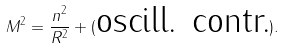Convert formula to latex. <formula><loc_0><loc_0><loc_500><loc_500>M ^ { 2 } = \frac { n ^ { 2 } } { R ^ { 2 } } + ( \text {oscill. contr.} ) .</formula> 